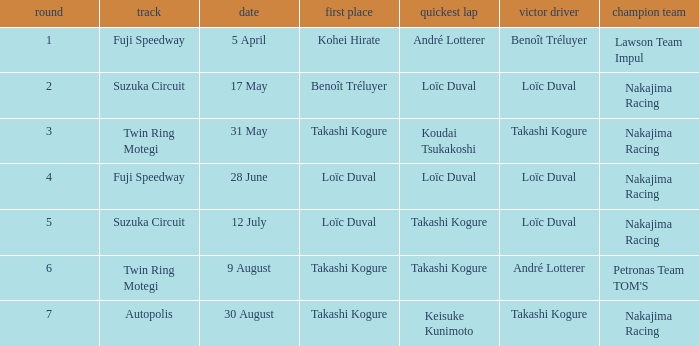Who has the fastest lap where Benoît Tréluyer got the pole position? Loïc Duval. 